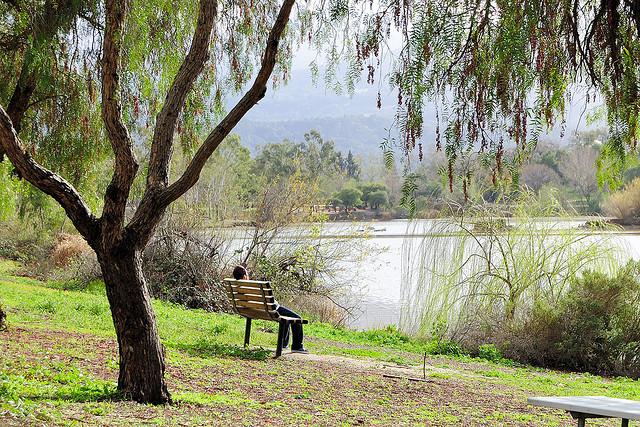How many tree trunks are in the picture?
Keep it brief. 1. IS the person physically active?
Concise answer only. No. How many trees are there?
Give a very brief answer. 1. Is this a peaceful scene?
Quick response, please. Yes. Is the person alone?
Give a very brief answer. Yes. 